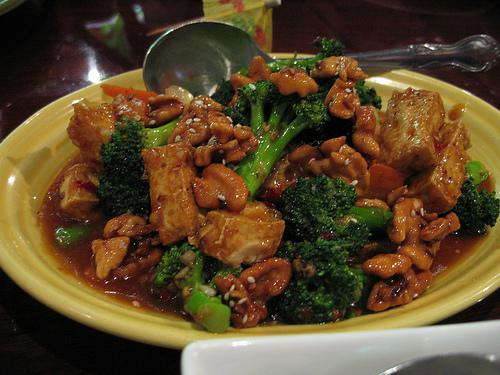Question: what color is the spoon in the dish?
Choices:
A. White.
B. Silver.
C. Chrome colored.
D. Pewter.
Answer with the letter. Answer: B Question: what vegetable is in the dish?
Choices:
A. Carrots.
B. Broccoli.
C. Lima beans.
D. Spinich.
Answer with the letter. Answer: B Question: why is there a spoon with the food?
Choices:
A. To sitr it.
B. To serve it.
C. To eat it.
D. Forgot to take it out.
Answer with the letter. Answer: B Question: what is on the dish?
Choices:
A. Leftovers.
B. Dirt.
C. Water spots.
D. Food.
Answer with the letter. Answer: D 